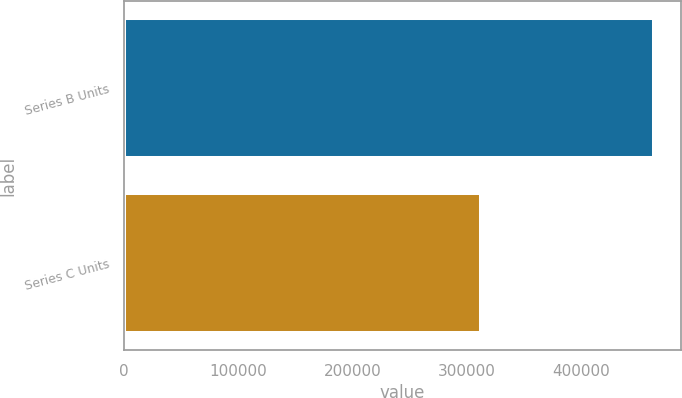Convert chart to OTSL. <chart><loc_0><loc_0><loc_500><loc_500><bar_chart><fcel>Series B Units<fcel>Series C Units<nl><fcel>464033<fcel>312075<nl></chart> 